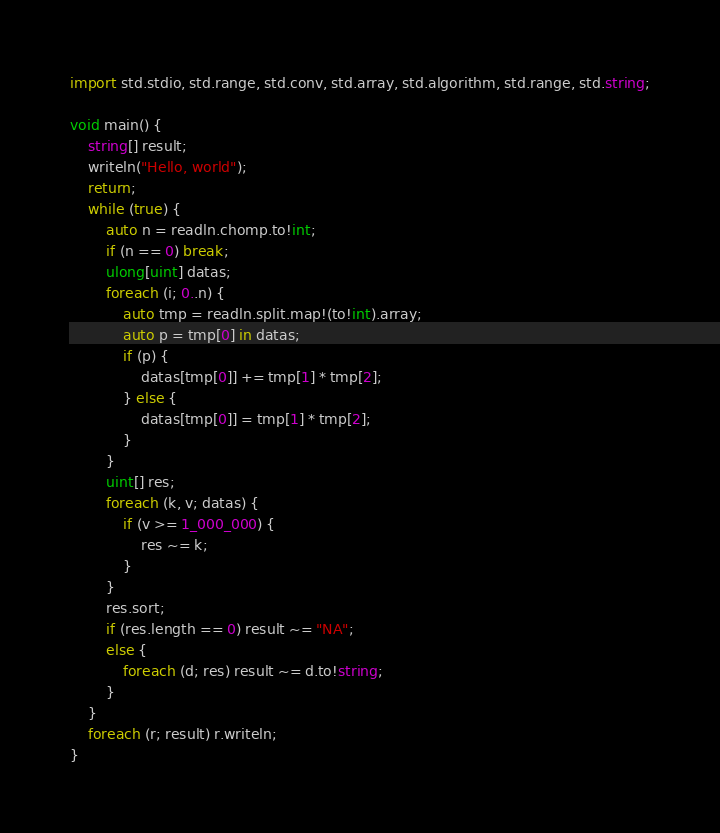Convert code to text. <code><loc_0><loc_0><loc_500><loc_500><_D_>import std.stdio, std.range, std.conv, std.array, std.algorithm, std.range, std.string;

void main() {
	string[] result;
	writeln("Hello, world");
	return;
	while (true) {
		auto n = readln.chomp.to!int;
		if (n == 0) break;
		ulong[uint] datas;
		foreach (i; 0..n) {
			auto tmp = readln.split.map!(to!int).array;
			auto p = tmp[0] in datas;
			if (p) {
				datas[tmp[0]] += tmp[1] * tmp[2];
			} else {
				datas[tmp[0]] = tmp[1] * tmp[2];
			}
		}
		uint[] res;
		foreach (k, v; datas) {
			if (v >= 1_000_000) {
				res ~= k;
			}
		}
		res.sort;
		if (res.length == 0) result ~= "NA"; 
		else {
			foreach (d; res) result ~= d.to!string; 
		}
	}
	foreach (r; result) r.writeln;
}</code> 